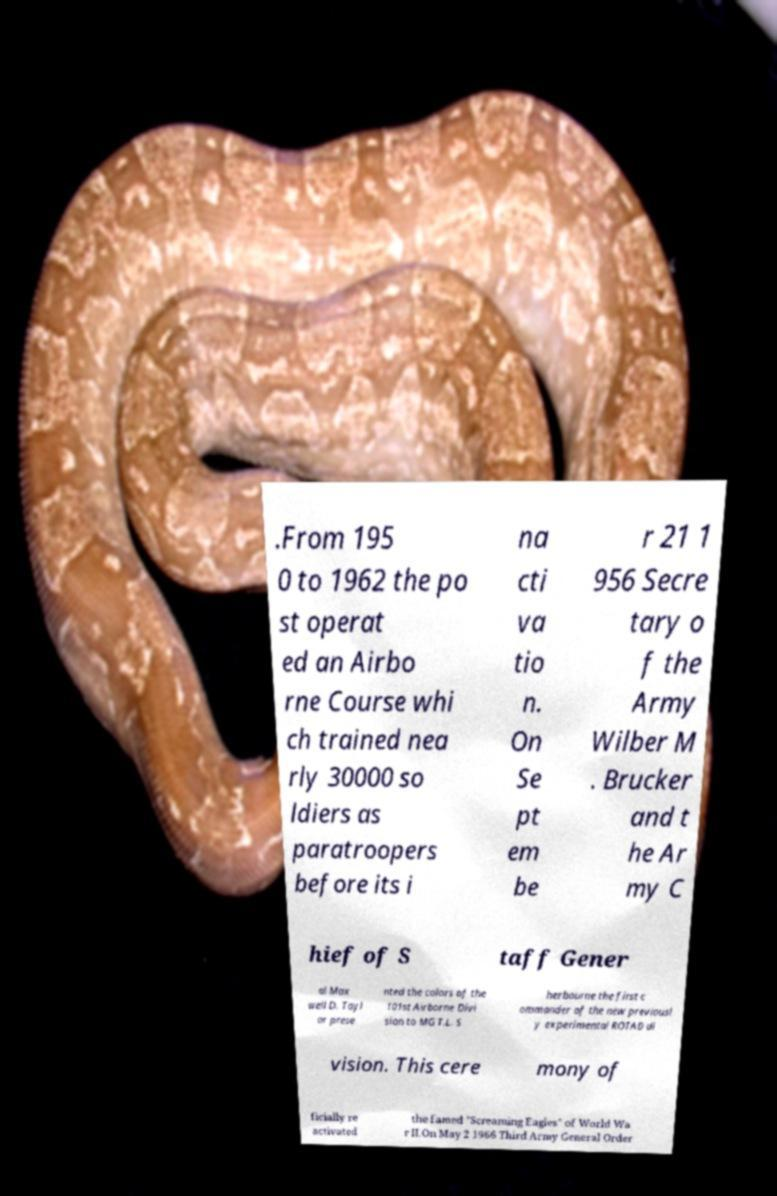Can you read and provide the text displayed in the image?This photo seems to have some interesting text. Can you extract and type it out for me? .From 195 0 to 1962 the po st operat ed an Airbo rne Course whi ch trained nea rly 30000 so ldiers as paratroopers before its i na cti va tio n. On Se pt em be r 21 1 956 Secre tary o f the Army Wilber M . Brucker and t he Ar my C hief of S taff Gener al Max well D. Tayl or prese nted the colors of the 101st Airborne Divi sion to MG T.L. S herbourne the first c ommander of the new previousl y experimental ROTAD di vision. This cere mony of ficially re activated the famed "Screaming Eagles" of World Wa r II.On May 2 1966 Third Army General Order 